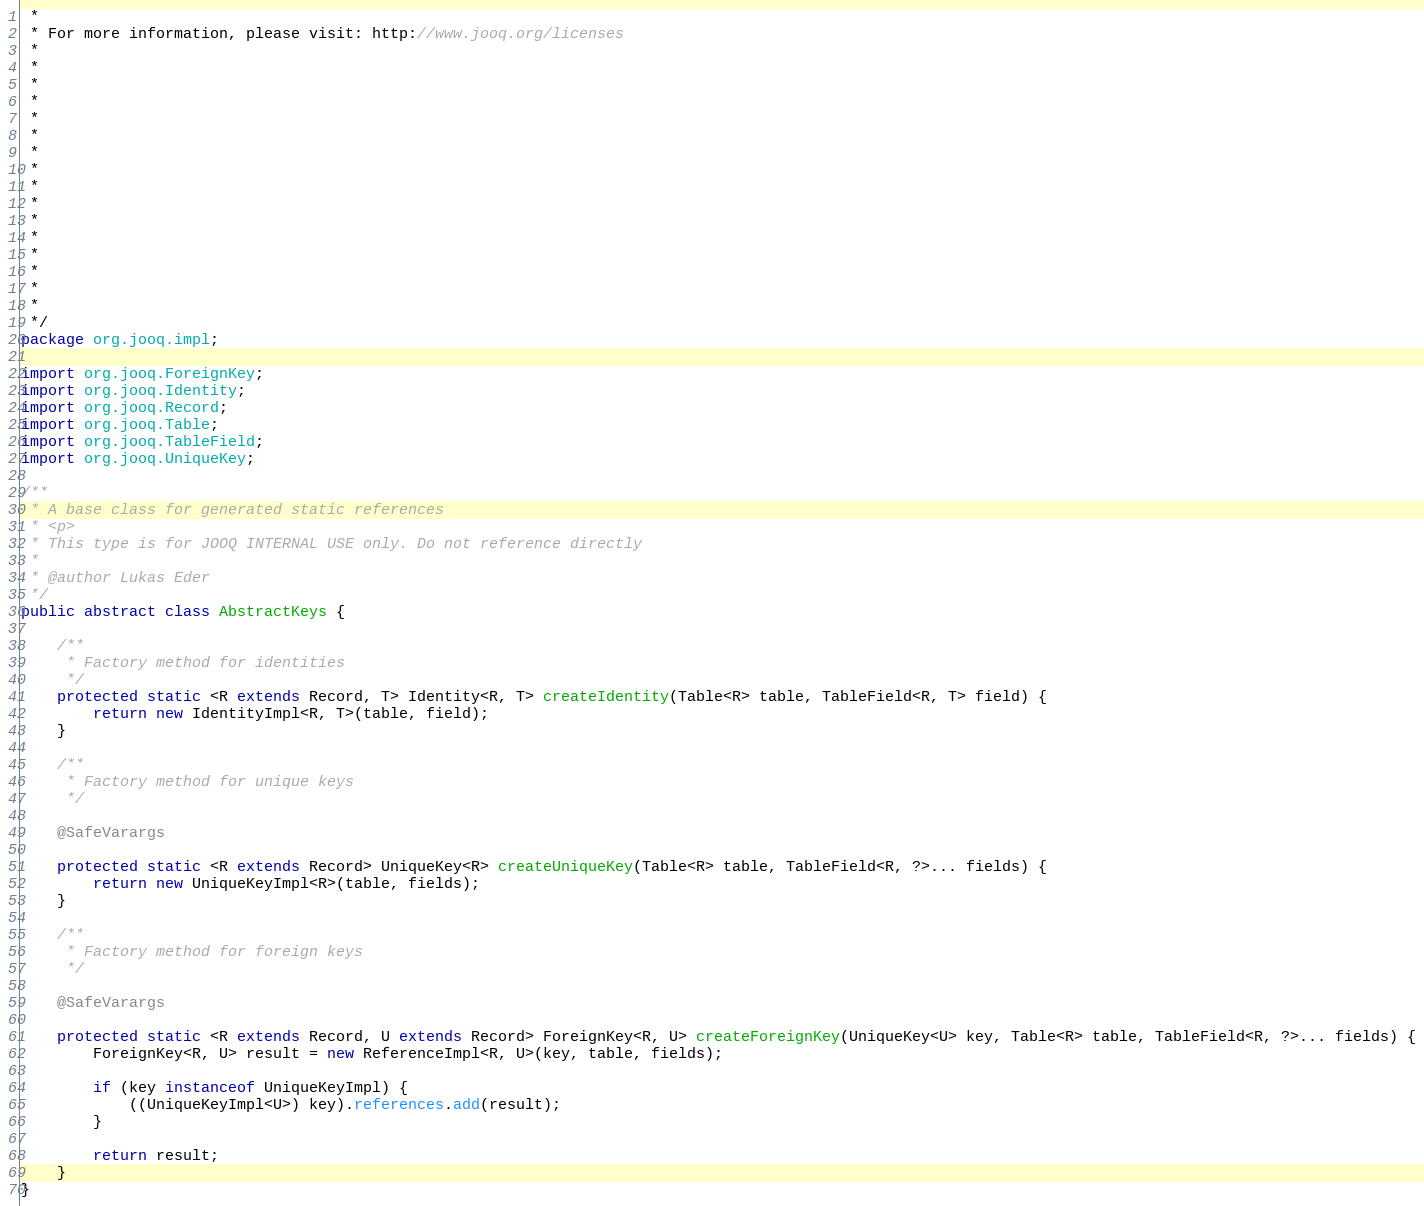<code> <loc_0><loc_0><loc_500><loc_500><_Java_> *
 * For more information, please visit: http://www.jooq.org/licenses
 *
 *
 *
 *
 *
 *
 *
 *
 *
 *
 *
 *
 *
 *
 *
 *
 */
package org.jooq.impl;

import org.jooq.ForeignKey;
import org.jooq.Identity;
import org.jooq.Record;
import org.jooq.Table;
import org.jooq.TableField;
import org.jooq.UniqueKey;

/**
 * A base class for generated static references
 * <p>
 * This type is for JOOQ INTERNAL USE only. Do not reference directly
 *
 * @author Lukas Eder
 */
public abstract class AbstractKeys {

    /**
     * Factory method for identities
     */
    protected static <R extends Record, T> Identity<R, T> createIdentity(Table<R> table, TableField<R, T> field) {
        return new IdentityImpl<R, T>(table, field);
    }

    /**
     * Factory method for unique keys
     */
    
    @SafeVarargs
    
    protected static <R extends Record> UniqueKey<R> createUniqueKey(Table<R> table, TableField<R, ?>... fields) {
        return new UniqueKeyImpl<R>(table, fields);
    }

    /**
     * Factory method for foreign keys
     */
    
    @SafeVarargs
    
    protected static <R extends Record, U extends Record> ForeignKey<R, U> createForeignKey(UniqueKey<U> key, Table<R> table, TableField<R, ?>... fields) {
        ForeignKey<R, U> result = new ReferenceImpl<R, U>(key, table, fields);

        if (key instanceof UniqueKeyImpl) {
            ((UniqueKeyImpl<U>) key).references.add(result);
        }

        return result;
    }
}
</code> 